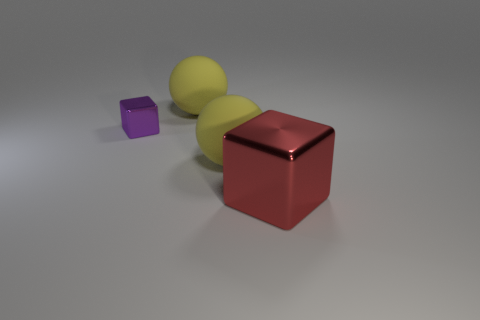Add 4 big matte balls. How many objects exist? 8 Subtract all purple cubes. Subtract all green spheres. How many cubes are left? 1 Subtract all purple cylinders. How many gray balls are left? 0 Subtract all tiny green metallic cylinders. Subtract all large yellow matte balls. How many objects are left? 2 Add 4 shiny blocks. How many shiny blocks are left? 6 Add 1 big yellow objects. How many big yellow objects exist? 3 Subtract 0 cyan cylinders. How many objects are left? 4 Subtract 2 cubes. How many cubes are left? 0 